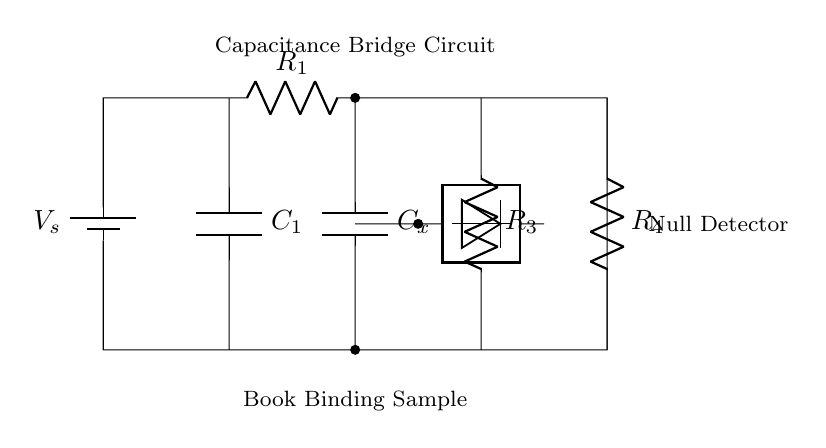What is the power source in this circuit? The power source is indicated as a battery, labeled V_s, which provides the necessary voltage for the circuit.
Answer: battery What are the values of components labeled R1 and R3? The values of R1 and R3 are not specified in the circuit diagram, but their symbols indicate they are resistors.
Answer: unspecified What type of component is Cx? Cx is labeled as a capacitor in the circuit diagram, indicated by the symbol C.
Answer: capacitor What is the role of the null detector? The null detector measures the balance of the bridge circuit and indicates when the voltage across it is zero, signaling equal capacitance in its branches.
Answer: measure balance Which component represents the sample being tested? The component labeled as Book Binding Sample indicates the material under analysis for its dielectric properties.
Answer: Book Binding Sample How many resistors are present in the circuit? There are three resistors present; they are R1, R3, and R4, based on their respective labels in the diagram.
Answer: three Why is C1 connected to the negative side of the sample? C1 is connected to ground, ensuring the correct reference point for measuring the capacitance of the Book Binding Sample when comparing with the known capacitance.
Answer: ground reference 